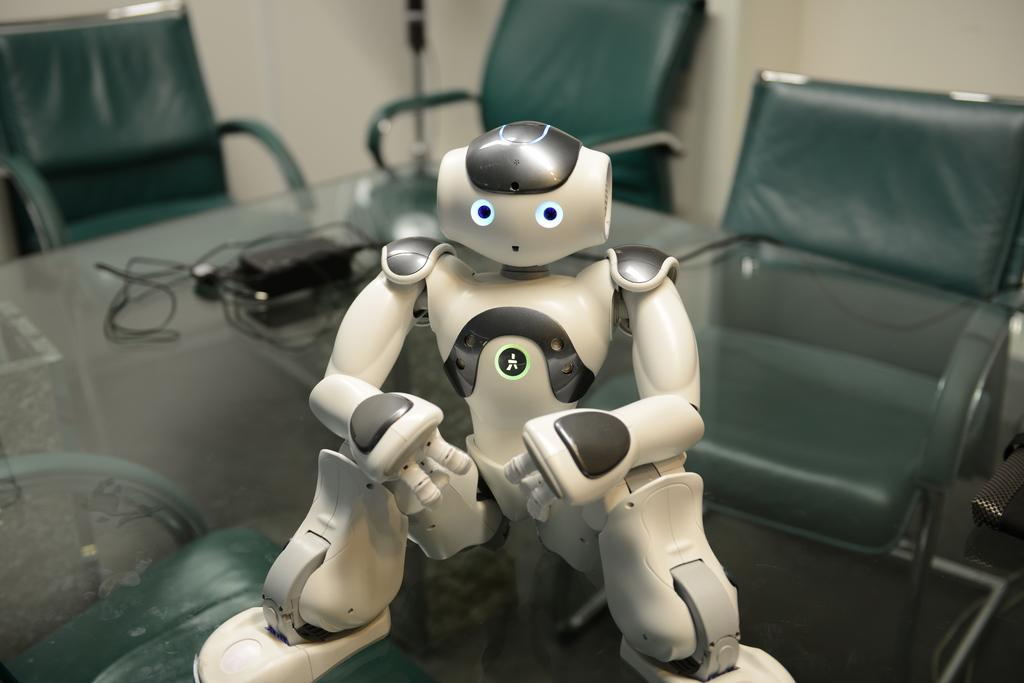What can be seen in the background of the image? There is a wall in the background of the image. What furniture is present in the image? There are chairs near a table in the image. What is the main object on the table? There is a robot on the table. What electronic device is present on the table? There is an adapter on the table. What type of statement can be seen on the chairs in the image? There are no statements present on the chairs in the image. What type of bushes can be seen growing near the wall in the image? There are no bushes visible in the image; only a wall is present in the background. 